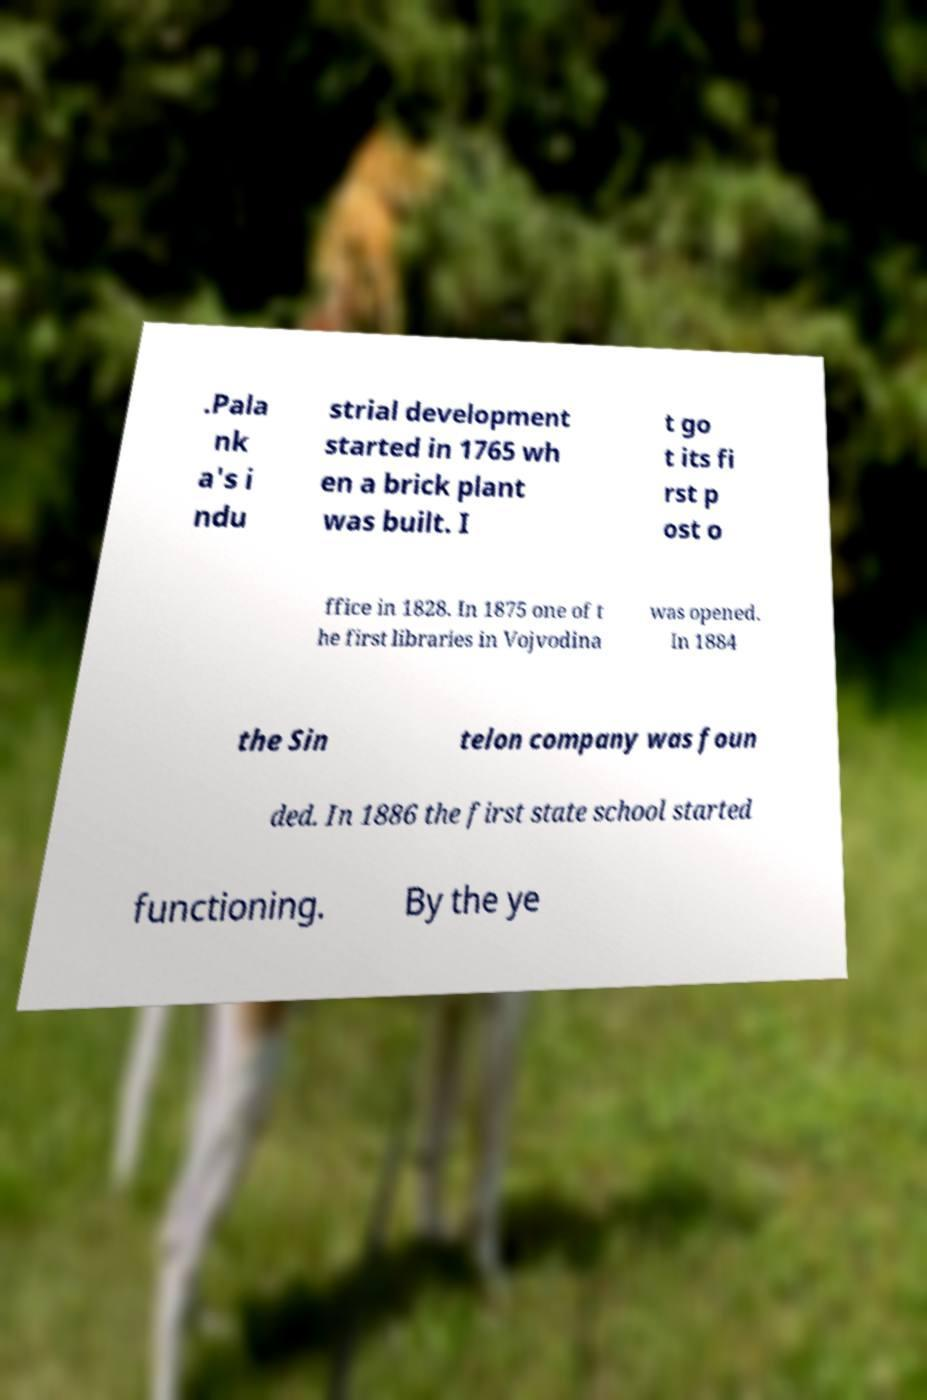There's text embedded in this image that I need extracted. Can you transcribe it verbatim? .Pala nk a's i ndu strial development started in 1765 wh en a brick plant was built. I t go t its fi rst p ost o ffice in 1828. In 1875 one of t he first libraries in Vojvodina was opened. In 1884 the Sin telon company was foun ded. In 1886 the first state school started functioning. By the ye 